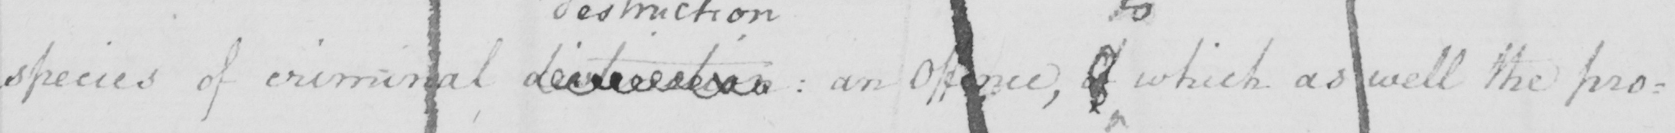Please transcribe the handwritten text in this image. species of criminal destruction  :  an Offence , of which as well the pro= 